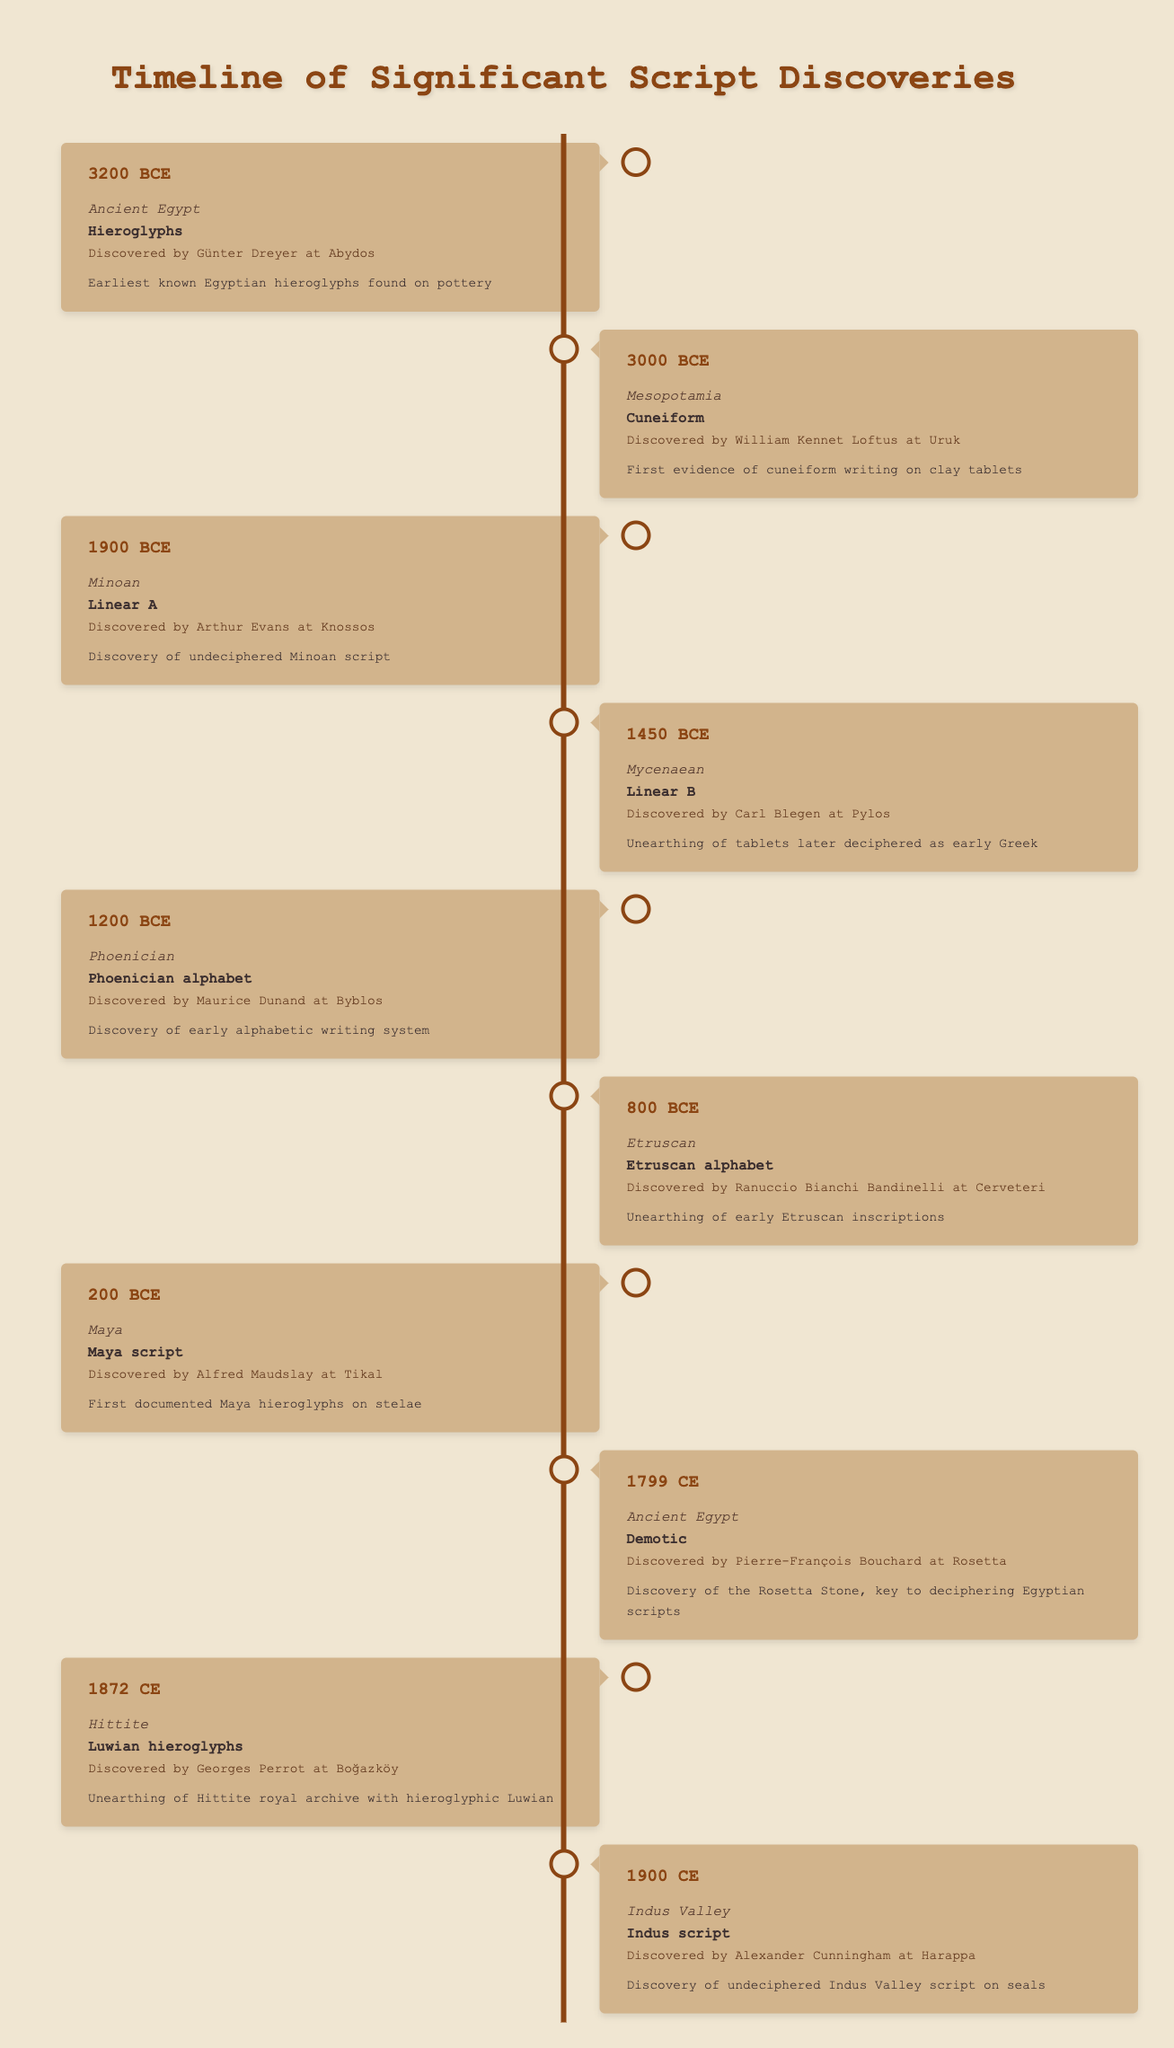What year were the earliest Egyptian hieroglyphs discovered? The entry for Ancient Egypt provides the year as "-3200," which indicates the discovery of the earliest known Egyptian hieroglyphs at Abydos.
Answer: -3200 Which civilization's script was first discovered in Mesopotamia? The table indicates the script discovered in Mesopotamia was "Cuneiform," as noted in the entry from the year "-3000."
Answer: Cuneiform Did the Maya civilization have a deciphered script? The entry for the Maya civilization shows that they had the "Maya script," which was described as undeciphered on the stelae discovered at Tikal.
Answer: No Who discovered the Luwian hieroglyphs and where? According to the entry under the Hittite civilization from the year "1872," the Luwian hieroglyphs were discovered by Georges Perrot at Boğazköy.
Answer: Georges Perrot at Boğazköy What civilization's script was discovered last in the timeline? The last entry in the timeline is for the "Indus Valley," with the discovery of the "Indus script" in the year "1900."
Answer: Indus Valley Is the Phoenician alphabet older than the Etruscan alphabet? The Phoenician alphabet was discovered in "-1200," and the Etruscan alphabet in "-800." Since "-1200" is before "-800," the Phoenician alphabet is indeed older.
Answer: Yes What is the significance of the Rosetta Stone as described in the timeline? The entry for Ancient Egypt in "1799" states that the discovery of the Rosetta Stone was key to deciphering Egyptian scripts, making it significant for understanding hieroglyphs.
Answer: Key to deciphering Egyptian scripts How many script discoveries are recorded for Ancient Egypt in this timeline? The timeline shows two entries for Ancient Egypt: the discovery of Hieroglyphs in "-3200" and Demotic scripts in "1799." Thus, there are two significant script discoveries recorded.
Answer: 2 